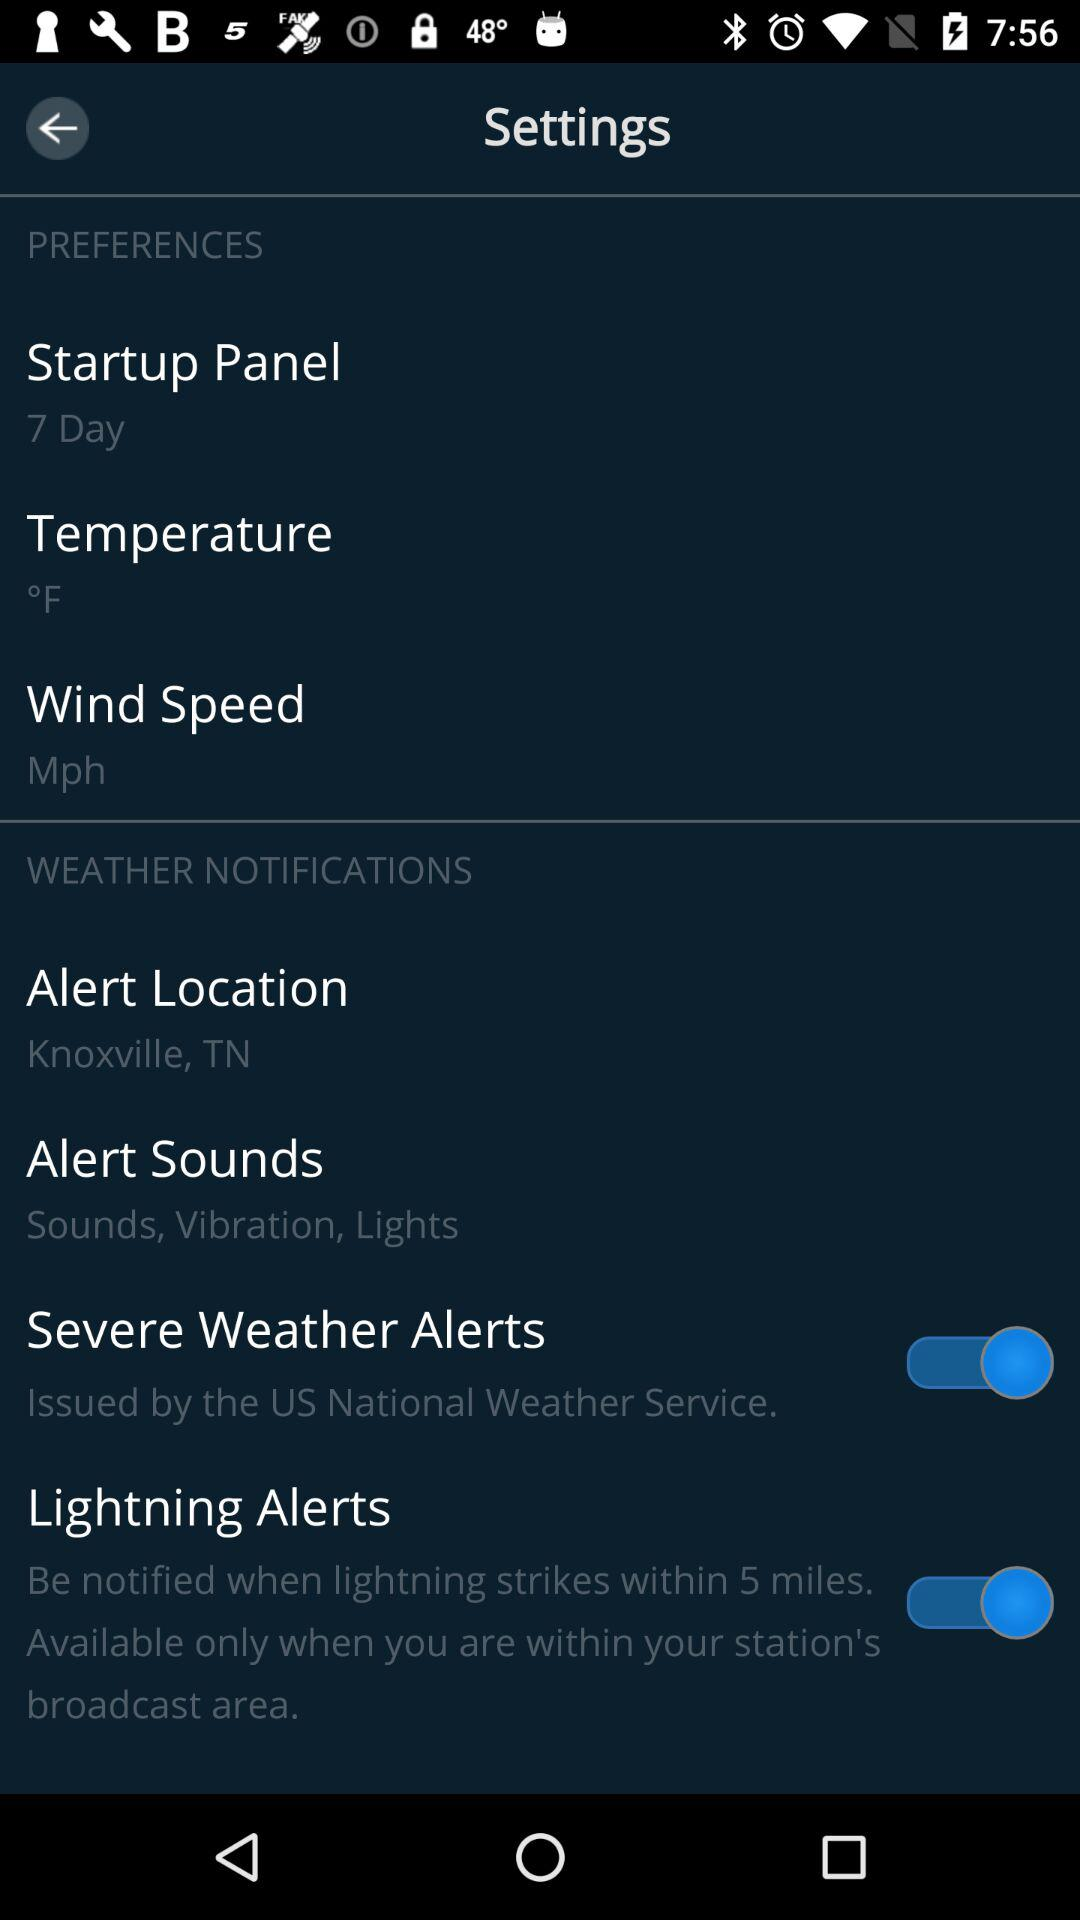How many days are there in the "Startup Panel"? There are 7 days in the "Startup Panel". 